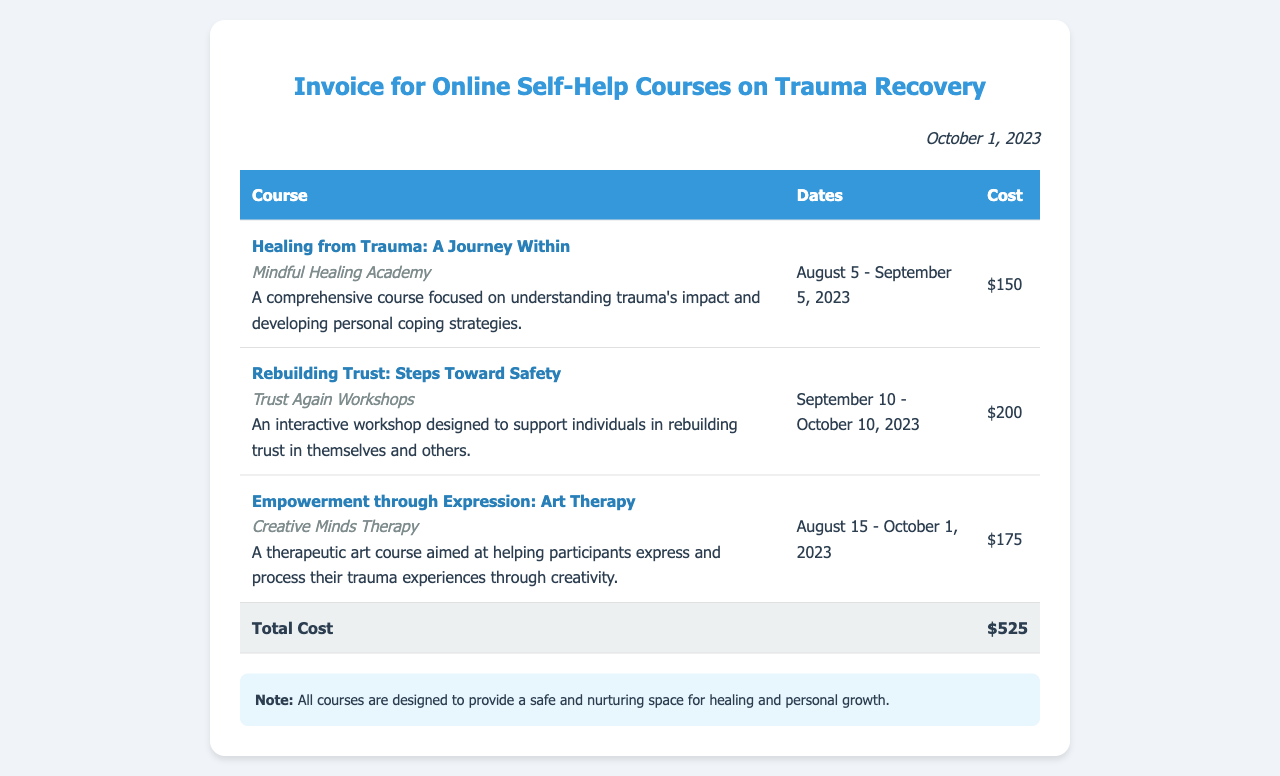What is the title of the first course? The title of the first course is listed in the document as "Healing from Trauma: A Journey Within."
Answer: Healing from Trauma: A Journey Within Which organization provides the second course? The provider of the second course is shown in the document as "Trust Again Workshops."
Answer: Trust Again Workshops What is the cost of the art therapy course? The cost of the art therapy course is mentioned as $175.
Answer: $175 How many total courses are listed on the invoice? The document lists three courses, which can be counted from the table.
Answer: 3 What is the total cost of all courses combined? The total cost is provided in the document as $525.
Answer: $525 In which month does the "Rebuilding Trust" course end? The end date of the "Rebuilding Trust" course is October 10, 2023, which indicates it ends in October.
Answer: October What is the duration of the “Healing from Trauma” course? The duration is from August 5 to September 5, 2023, indicating it lasts one month.
Answer: One month What is the purpose of the courses as stated in the notes? The purpose of the courses is described in the notes, which states to provide a safe and nurturing space for healing and personal growth.
Answer: Healing and personal growth 